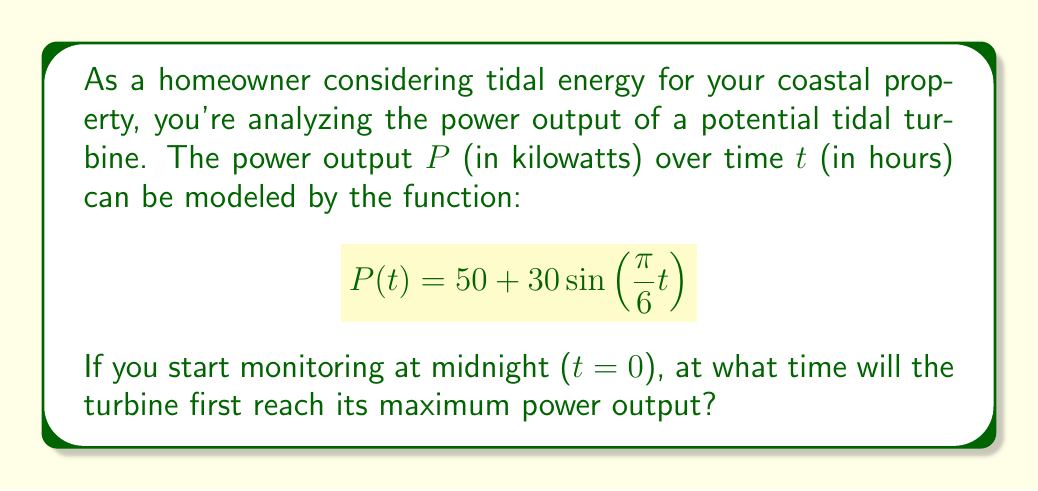Teach me how to tackle this problem. Let's approach this step-by-step:

1) The given function is a sinusoidal function in the form:
   $$f(t) = A\sin(Bt) + C$$
   Where A = 30 (amplitude), B = $\frac{\pi}{6}$ (angular frequency), and C = 50 (vertical shift).

2) The period of this function is:
   $$\text{Period} = \frac{2\pi}{B} = \frac{2\pi}{\frac{\pi}{6}} = 12 \text{ hours}$$
   This corresponds to the tidal cycle of approximately 12 hours.

3) The maximum value of a sine function occurs when $\sin(Bt) = 1$, which happens when $Bt = \frac{\pi}{2}$ (or 90°).

4) So, we need to solve:
   $$\frac{\pi}{6}t = \frac{\pi}{2}$$

5) Solving for t:
   $$t = \frac{\frac{\pi}{2}}{\frac{\pi}{6}} = 3 \text{ hours}$$

6) Since we started at midnight (t = 0), the maximum power output will occur 3 hours later, which is 3:00 AM.

This aligns with the nature of tidal energy, where maximum power often occurs a few hours after high or low tide.
Answer: The turbine will first reach its maximum power output at 3:00 AM. 